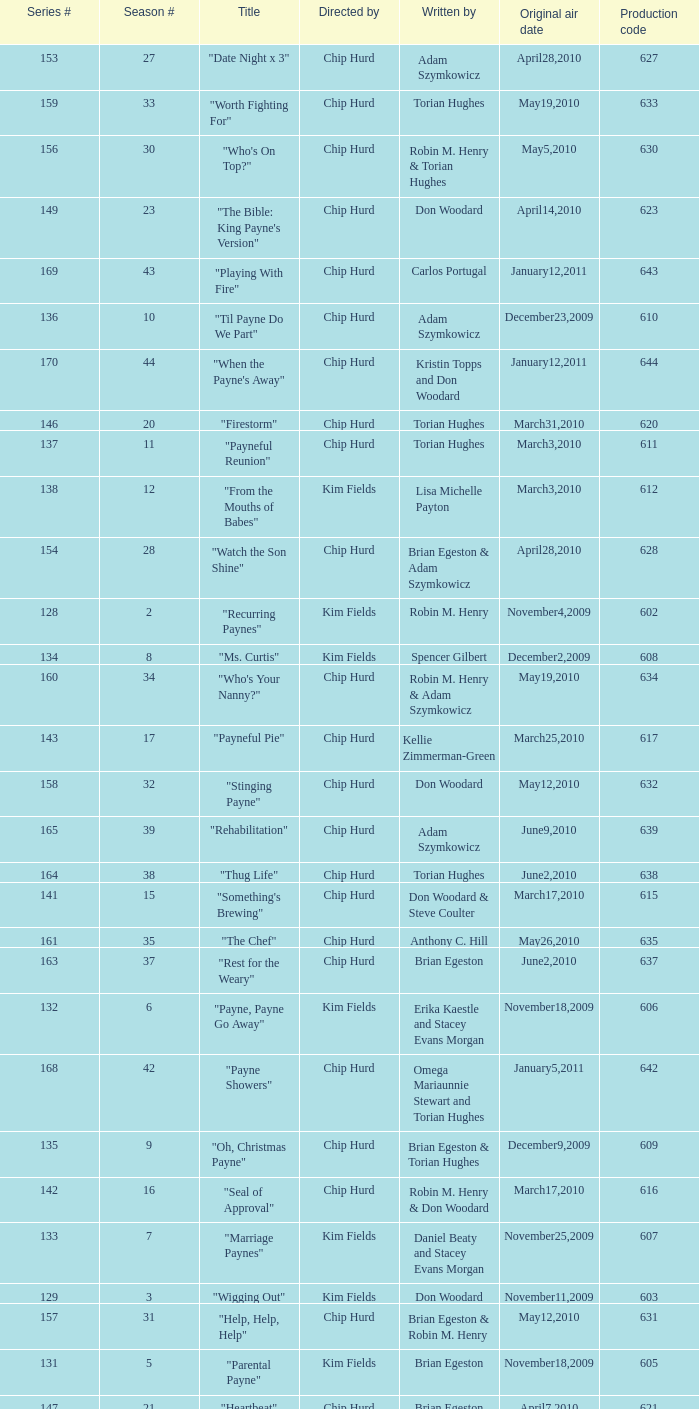What is the original air date of the episode written by Karen Felix and Don Woodard? May5,2010. Help me parse the entirety of this table. {'header': ['Series #', 'Season #', 'Title', 'Directed by', 'Written by', 'Original air date', 'Production code'], 'rows': [['153', '27', '"Date Night x 3"', 'Chip Hurd', 'Adam Szymkowicz', 'April28,2010', '627'], ['159', '33', '"Worth Fighting For"', 'Chip Hurd', 'Torian Hughes', 'May19,2010', '633'], ['156', '30', '"Who\'s On Top?"', 'Chip Hurd', 'Robin M. Henry & Torian Hughes', 'May5,2010', '630'], ['149', '23', '"The Bible: King Payne\'s Version"', 'Chip Hurd', 'Don Woodard', 'April14,2010', '623'], ['169', '43', '"Playing With Fire"', 'Chip Hurd', 'Carlos Portugal', 'January12,2011', '643'], ['136', '10', '"Til Payne Do We Part"', 'Chip Hurd', 'Adam Szymkowicz', 'December23,2009', '610'], ['170', '44', '"When the Payne\'s Away"', 'Chip Hurd', 'Kristin Topps and Don Woodard', 'January12,2011', '644'], ['146', '20', '"Firestorm"', 'Chip Hurd', 'Torian Hughes', 'March31,2010', '620'], ['137', '11', '"Payneful Reunion"', 'Chip Hurd', 'Torian Hughes', 'March3,2010', '611'], ['138', '12', '"From the Mouths of Babes"', 'Kim Fields', 'Lisa Michelle Payton', 'March3,2010', '612'], ['154', '28', '"Watch the Son Shine"', 'Chip Hurd', 'Brian Egeston & Adam Szymkowicz', 'April28,2010', '628'], ['128', '2', '"Recurring Paynes"', 'Kim Fields', 'Robin M. Henry', 'November4,2009', '602'], ['134', '8', '"Ms. Curtis"', 'Kim Fields', 'Spencer Gilbert', 'December2,2009', '608'], ['160', '34', '"Who\'s Your Nanny?"', 'Chip Hurd', 'Robin M. Henry & Adam Szymkowicz', 'May19,2010', '634'], ['143', '17', '"Payneful Pie"', 'Chip Hurd', 'Kellie Zimmerman-Green', 'March25,2010', '617'], ['158', '32', '"Stinging Payne"', 'Chip Hurd', 'Don Woodard', 'May12,2010', '632'], ['165', '39', '"Rehabilitation"', 'Chip Hurd', 'Adam Szymkowicz', 'June9,2010', '639'], ['164', '38', '"Thug Life"', 'Chip Hurd', 'Torian Hughes', 'June2,2010', '638'], ['141', '15', '"Something\'s Brewing"', 'Chip Hurd', 'Don Woodard & Steve Coulter', 'March17,2010', '615'], ['161', '35', '"The Chef"', 'Chip Hurd', 'Anthony C. Hill', 'May26,2010', '635'], ['163', '37', '"Rest for the Weary"', 'Chip Hurd', 'Brian Egeston', 'June2,2010', '637'], ['132', '6', '"Payne, Payne Go Away"', 'Kim Fields', 'Erika Kaestle and Stacey Evans Morgan', 'November18,2009', '606'], ['168', '42', '"Payne Showers"', 'Chip Hurd', 'Omega Mariaunnie Stewart and Torian Hughes', 'January5,2011', '642'], ['135', '9', '"Oh, Christmas Payne"', 'Chip Hurd', 'Brian Egeston & Torian Hughes', 'December9,2009', '609'], ['142', '16', '"Seal of Approval"', 'Chip Hurd', 'Robin M. Henry & Don Woodard', 'March17,2010', '616'], ['133', '7', '"Marriage Paynes"', 'Kim Fields', 'Daniel Beaty and Stacey Evans Morgan', 'November25,2009', '607'], ['129', '3', '"Wigging Out"', 'Kim Fields', 'Don Woodard', 'November11,2009', '603'], ['157', '31', '"Help, Help, Help"', 'Chip Hurd', 'Brian Egeston & Robin M. Henry', 'May12,2010', '631'], ['131', '5', '"Parental Payne"', 'Kim Fields', 'Brian Egeston', 'November18,2009', '605'], ['147', '21', '"Heartbeat"', 'Chip Hurd', 'Brian Egeston', 'April7,2010', '621'], ['151', '25', '"Who\'s Your Daddy Now?"', 'Chip Hurd', 'Brian Egeston', 'April21,2010', '625'], ['144', '18', '"How Do You Like Your Roast?"', 'Chip Hurd', 'Robin M. Henry & Steve Coulter', 'March25,2010', '618'], ['145', '19', '"Curtis Sings the Blues"', 'Chip Hurd', 'Robin M. Henry & Don Woodard', 'March31,2010', '619'], ['140', '14', '"Lady Sings the Blues"', 'Chip Hurd', 'Steve Coulter & Don Woodard', 'March10,2010', '614'], ['150', '24', '"Matured Investment"', 'Chip Hurd', 'Torian Hughes', 'April14,2010', '624'], ['155', '29', '"Drinking Game"', 'Chip Hurd', 'Karen Felix and Don Woodard', 'May5,2010', '629'], ['167', '41', '"House Guest"', 'Chip Hurd', 'David A. Arnold', 'January5,2011', '641'], ['152', '26', '"Feet of Clay"', 'Chip Hurd', 'Don Woodard', 'April21,2010', '626'], ['148', '22', '"Through the Fire"', 'Chip Hurd', 'Robin M. Henry', 'April7,2010', '622'], ['139', '13', '"Blackout X 3"', 'Kim Fields', 'Adam Szymkowicz', 'March10,2010', '613'], ['130', '4', '"Payne Speaking"', 'Kim Fields', 'Don Woodard', 'November11,2009', '604'], ['162', '36', '"My Fair Curtis"', 'Chip Hurd', 'Don Woodard', 'May26,2010', '636'], ['166', '40', '"A Payne In Need Is A Pain Indeed"', 'Chip Hurd', 'Don Woodard', 'June9,2010', '640'], ['127', '1', '"Where\'s the Payne?"', 'Kim Fields', 'Steve Coulter', 'November4,2009', '601'], ['171', '45', '"Beginnings"', 'Chip Hurd', 'Myra J.', 'January19,2011', '645']]} 